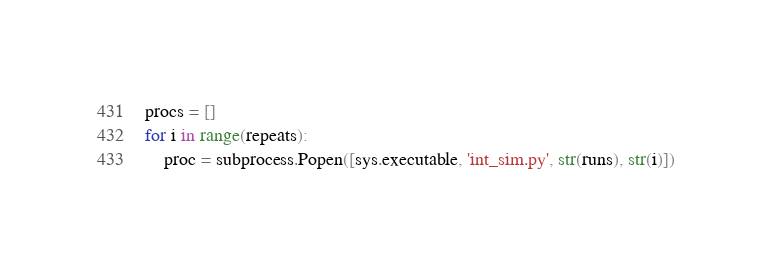<code> <loc_0><loc_0><loc_500><loc_500><_Python_>
procs = []
for i in range(repeats):
    proc = subprocess.Popen([sys.executable, 'int_sim.py', str(runs), str(i)])</code> 